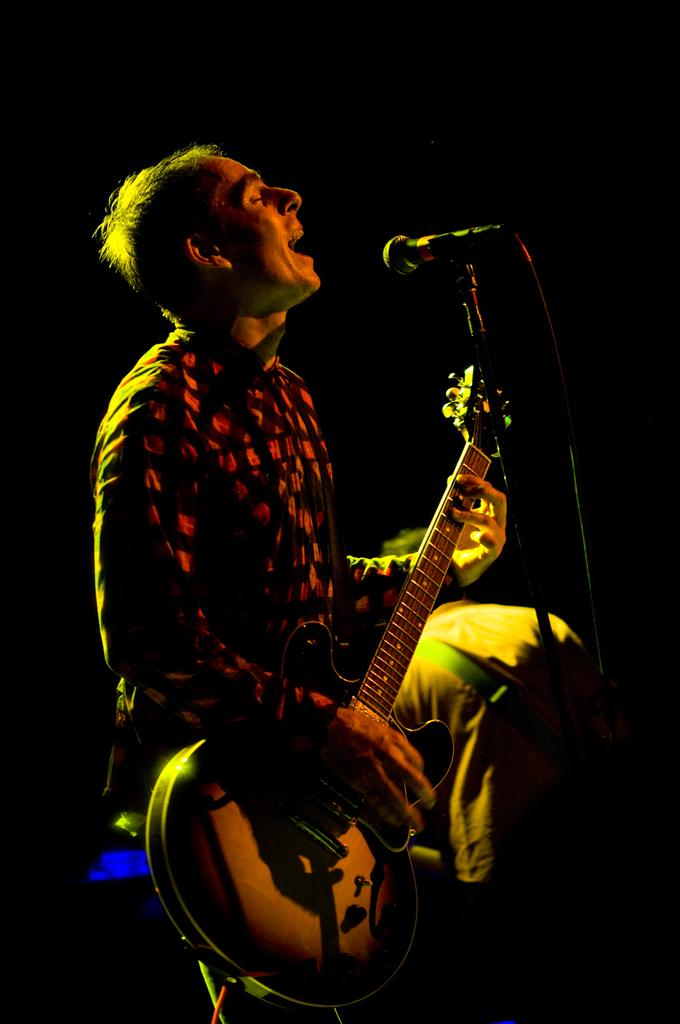What is the man in the image doing? The man is playing a guitar and singing. What object is present on the right side of the image? There is a microphone on the right side of the image. Can you describe the person in the background of the image? There is a person in the background of the image, but no specific details are provided. What type of winter clothing is the man wearing in the image? The image does not show the man wearing any winter clothing, as it does not depict a winter scene. 